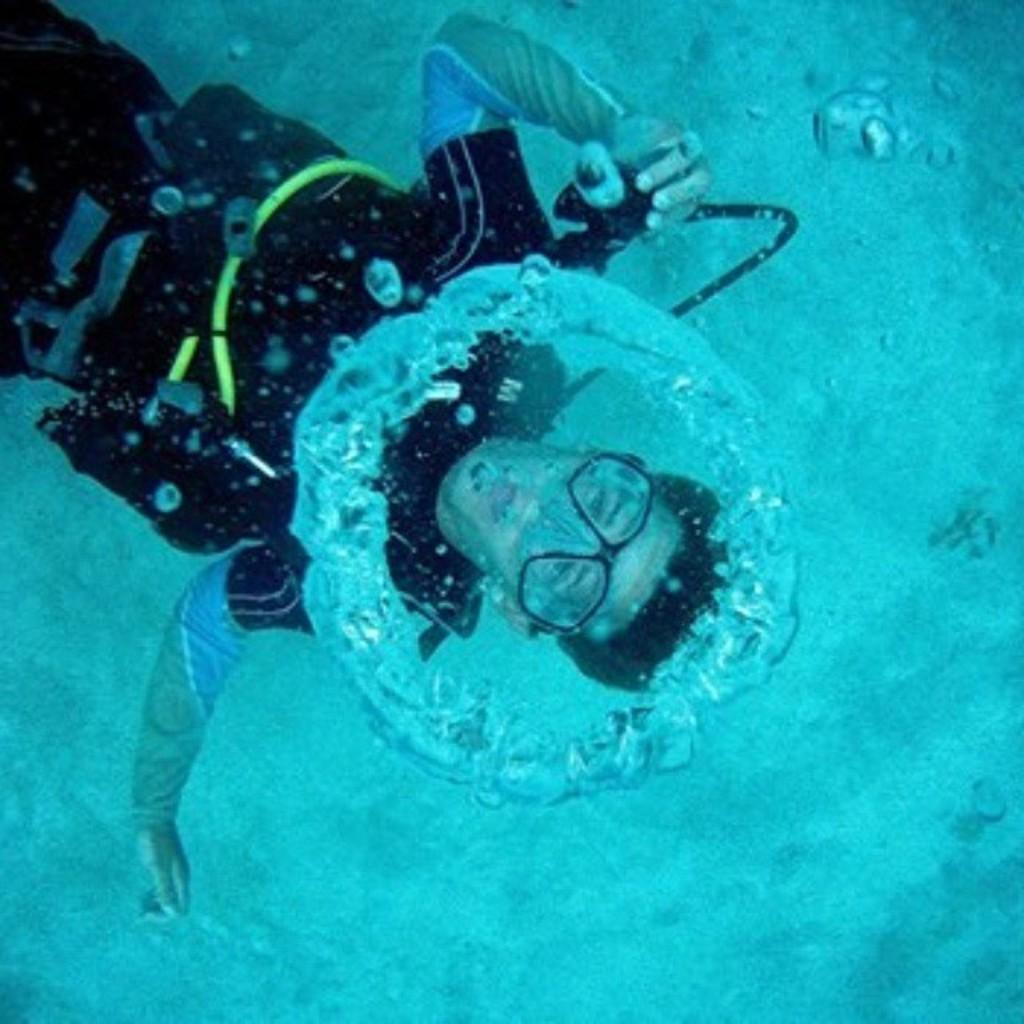Who is present in the image? There is a man in the image. What is the man's location in relation to the water? The man is inside the water. What type of insurance does the man have for his day at the beach? There is no information about insurance or a day at the beach in the image, so it cannot be determined. 